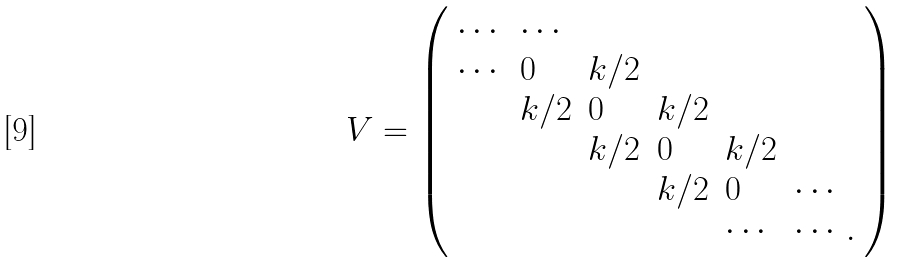Convert formula to latex. <formula><loc_0><loc_0><loc_500><loc_500>V = \left ( \begin{array} { l l l l l l } \cdots & \cdots & & & & \\ \cdots & 0 & k / 2 & & & \\ & k / 2 & 0 & k / 2 & & \\ & & k / 2 & 0 & k / 2 & \\ & & & k / 2 & 0 & \cdots \\ & & & & \cdots & \cdots . \end{array} \right )</formula> 